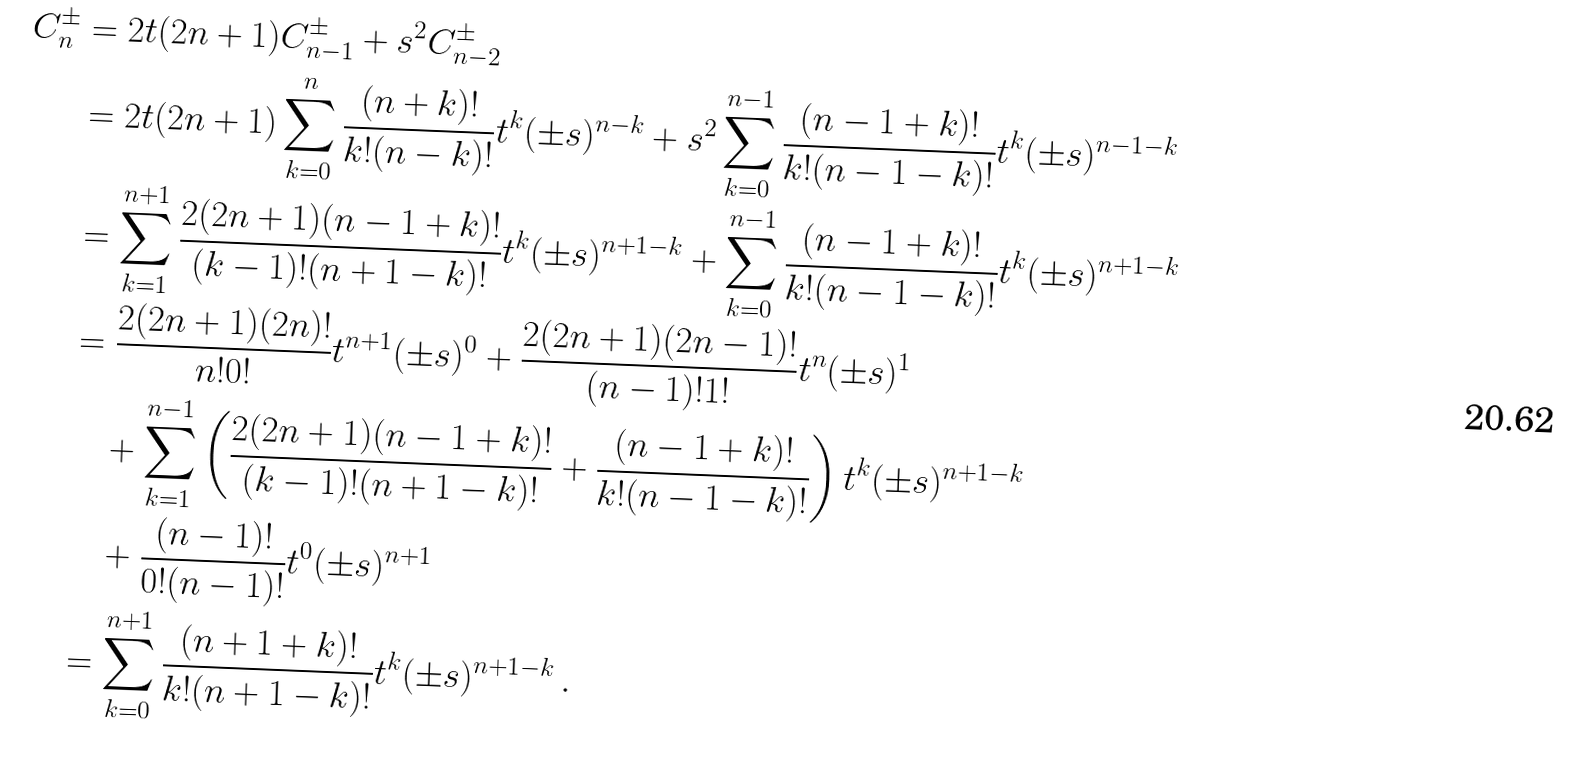<formula> <loc_0><loc_0><loc_500><loc_500>C ^ { \pm } _ { n } & = 2 t ( 2 n + 1 ) C ^ { \pm } _ { n - 1 } + s ^ { 2 } C ^ { \pm } _ { n - 2 } \\ & = 2 t ( 2 n + 1 ) \sum _ { k = 0 } ^ { n } \frac { ( n + k ) ! } { k ! ( n - k ) ! } t ^ { k } ( \pm s ) ^ { n - k } + s ^ { 2 } \sum _ { k = 0 } ^ { n - 1 } \frac { ( n - 1 + k ) ! } { k ! ( n - 1 - k ) ! } t ^ { k } ( \pm s ) ^ { n - 1 - k } \\ & = \sum _ { k = 1 } ^ { n + 1 } \frac { 2 ( 2 n + 1 ) ( n - 1 + k ) ! } { ( k - 1 ) ! ( n + 1 - k ) ! } t ^ { k } ( \pm s ) ^ { n + 1 - k } + \sum _ { k = 0 } ^ { n - 1 } \frac { ( n - 1 + k ) ! } { k ! ( n - 1 - k ) ! } t ^ { k } ( \pm s ) ^ { n + 1 - k } \\ & = \frac { 2 ( 2 n + 1 ) ( 2 n ) ! } { n ! 0 ! } t ^ { n + 1 } ( \pm s ) ^ { 0 } + \frac { 2 ( 2 n + 1 ) ( 2 n - 1 ) ! } { ( n - 1 ) ! 1 ! } t ^ { n } ( \pm s ) ^ { 1 } \\ & \quad + \sum _ { k = 1 } ^ { n - 1 } \left ( \frac { 2 ( 2 n + 1 ) ( n - 1 + k ) ! } { ( k - 1 ) ! ( n + 1 - k ) ! } + \frac { ( n - 1 + k ) ! } { k ! ( n - 1 - k ) ! } \right ) t ^ { k } ( \pm s ) ^ { n + 1 - k } \\ & \quad + \frac { ( n - 1 ) ! } { 0 ! ( n - 1 ) ! } t ^ { 0 } ( \pm s ) ^ { n + 1 } \\ & = \sum _ { k = 0 } ^ { n + 1 } \frac { ( n + 1 + k ) ! } { k ! ( n + 1 - k ) ! } t ^ { k } ( \pm s ) ^ { n + 1 - k } \, .</formula> 